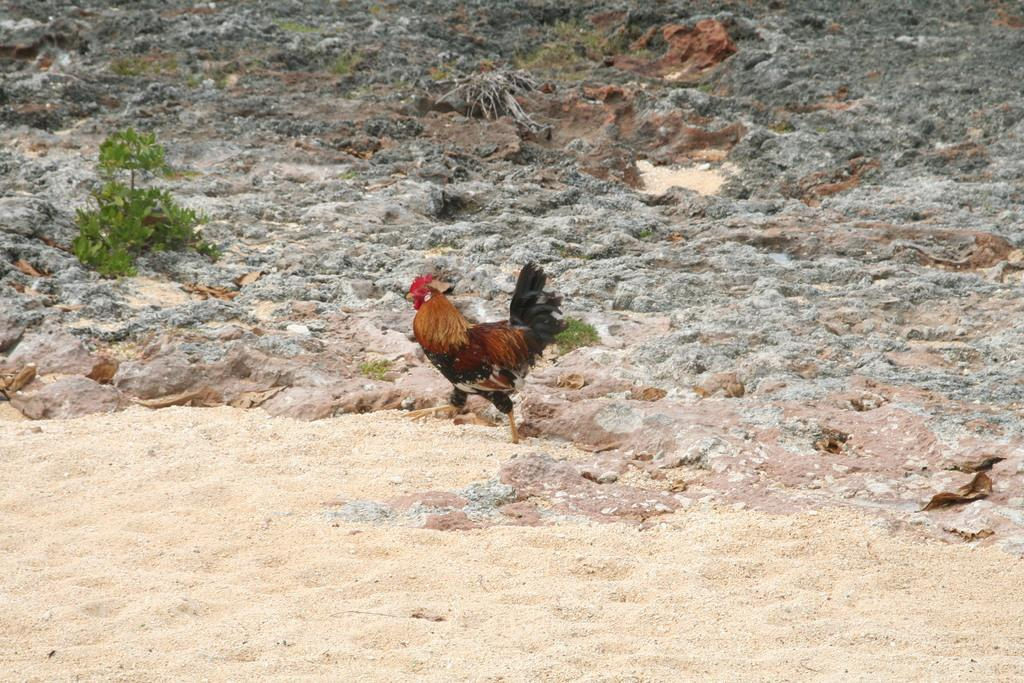What animal is present in the image? There is a hen in the image. Where is the hen located? The hen is on the sand. What can be seen behind the hen? There are plants and rocks behind the hen. What type of bottle is the hen holding in the image? There is no bottle present in the image; the hen is not holding anything. 